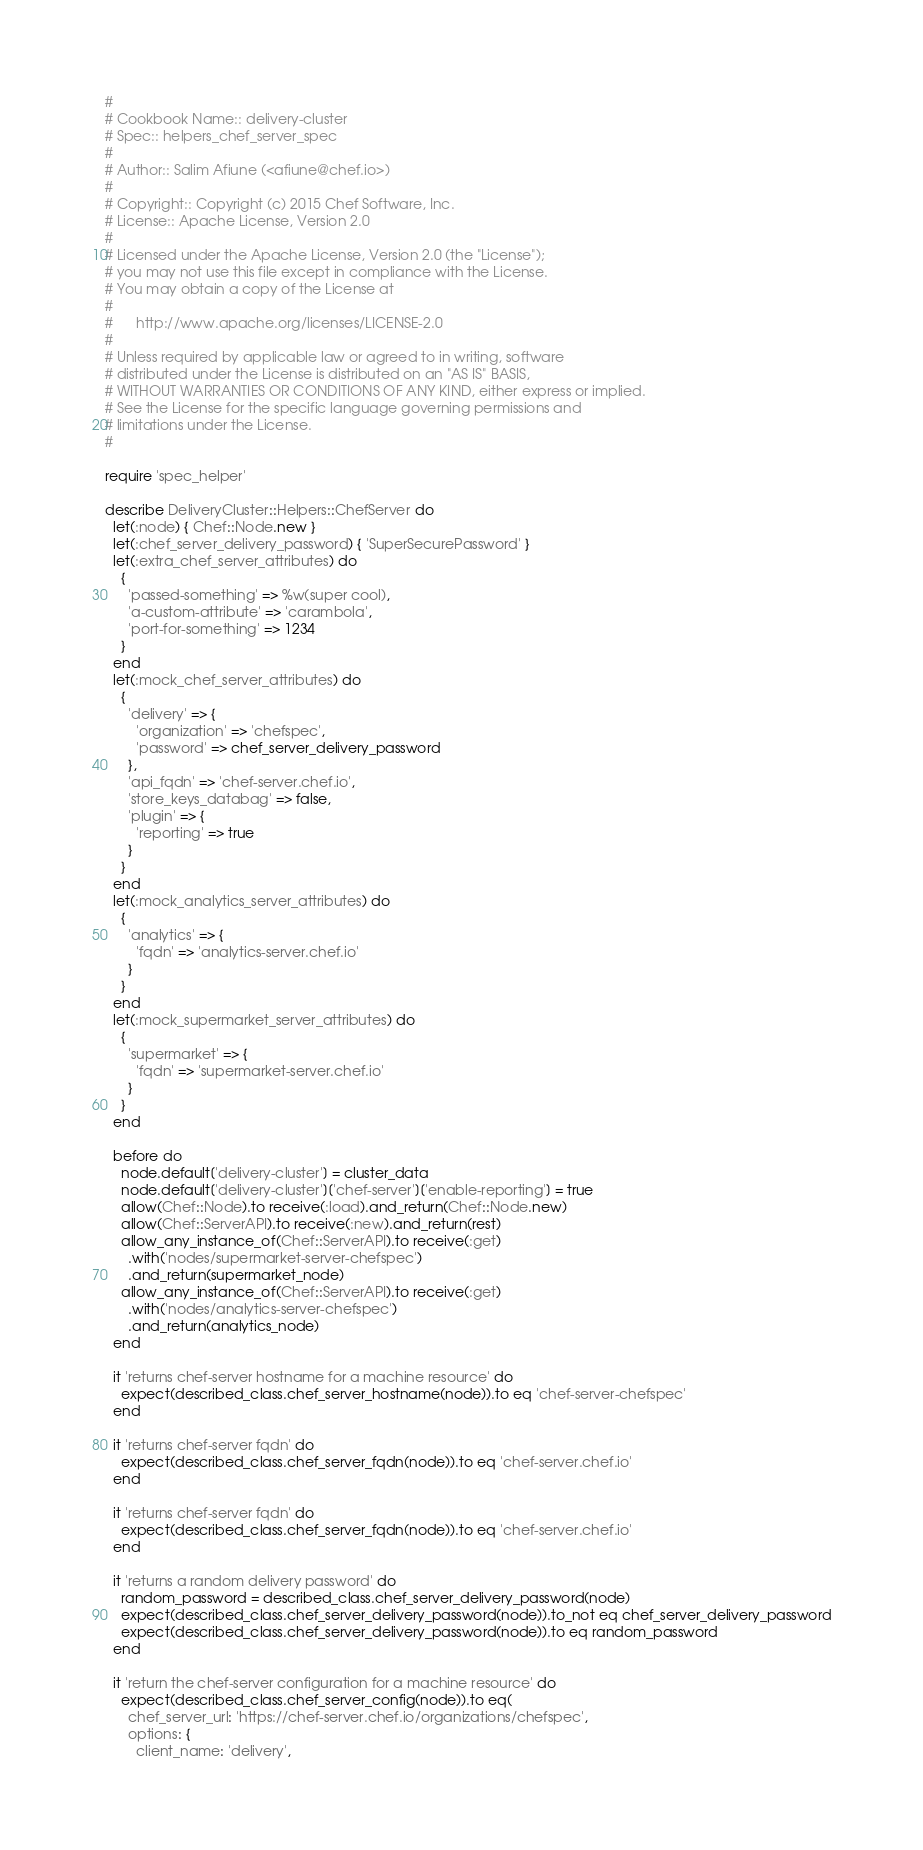<code> <loc_0><loc_0><loc_500><loc_500><_Ruby_>#
# Cookbook Name:: delivery-cluster
# Spec:: helpers_chef_server_spec
#
# Author:: Salim Afiune (<afiune@chef.io>)
#
# Copyright:: Copyright (c) 2015 Chef Software, Inc.
# License:: Apache License, Version 2.0
#
# Licensed under the Apache License, Version 2.0 (the "License");
# you may not use this file except in compliance with the License.
# You may obtain a copy of the License at
#
#      http://www.apache.org/licenses/LICENSE-2.0
#
# Unless required by applicable law or agreed to in writing, software
# distributed under the License is distributed on an "AS IS" BASIS,
# WITHOUT WARRANTIES OR CONDITIONS OF ANY KIND, either express or implied.
# See the License for the specific language governing permissions and
# limitations under the License.
#

require 'spec_helper'

describe DeliveryCluster::Helpers::ChefServer do
  let(:node) { Chef::Node.new }
  let(:chef_server_delivery_password) { 'SuperSecurePassword' }
  let(:extra_chef_server_attributes) do
    {
      'passed-something' => %w(super cool),
      'a-custom-attribute' => 'carambola',
      'port-for-something' => 1234
    }
  end
  let(:mock_chef_server_attributes) do
    {
      'delivery' => {
        'organization' => 'chefspec',
        'password' => chef_server_delivery_password
      },
      'api_fqdn' => 'chef-server.chef.io',
      'store_keys_databag' => false,
      'plugin' => {
        'reporting' => true
      }
    }
  end
  let(:mock_analytics_server_attributes) do
    {
      'analytics' => {
        'fqdn' => 'analytics-server.chef.io'
      }
    }
  end
  let(:mock_supermarket_server_attributes) do
    {
      'supermarket' => {
        'fqdn' => 'supermarket-server.chef.io'
      }
    }
  end

  before do
    node.default['delivery-cluster'] = cluster_data
    node.default['delivery-cluster']['chef-server']['enable-reporting'] = true
    allow(Chef::Node).to receive(:load).and_return(Chef::Node.new)
    allow(Chef::ServerAPI).to receive(:new).and_return(rest)
    allow_any_instance_of(Chef::ServerAPI).to receive(:get)
      .with('nodes/supermarket-server-chefspec')
      .and_return(supermarket_node)
    allow_any_instance_of(Chef::ServerAPI).to receive(:get)
      .with('nodes/analytics-server-chefspec')
      .and_return(analytics_node)
  end

  it 'returns chef-server hostname for a machine resource' do
    expect(described_class.chef_server_hostname(node)).to eq 'chef-server-chefspec'
  end

  it 'returns chef-server fqdn' do
    expect(described_class.chef_server_fqdn(node)).to eq 'chef-server.chef.io'
  end

  it 'returns chef-server fqdn' do
    expect(described_class.chef_server_fqdn(node)).to eq 'chef-server.chef.io'
  end

  it 'returns a random delivery password' do
    random_password = described_class.chef_server_delivery_password(node)
    expect(described_class.chef_server_delivery_password(node)).to_not eq chef_server_delivery_password
    expect(described_class.chef_server_delivery_password(node)).to eq random_password
  end

  it 'return the chef-server configuration for a machine resource' do
    expect(described_class.chef_server_config(node)).to eq(
      chef_server_url: 'https://chef-server.chef.io/organizations/chefspec',
      options: {
        client_name: 'delivery',</code> 